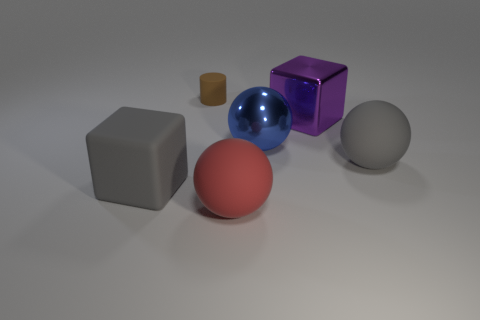What number of rubber cubes are there?
Your answer should be compact. 1. How many cubes are either large green rubber things or large blue metal objects?
Offer a very short reply. 0. There is another shiny sphere that is the same size as the red sphere; what color is it?
Keep it short and to the point. Blue. How many things are both in front of the purple cube and on the right side of the large blue object?
Offer a terse response. 1. What is the big red thing made of?
Give a very brief answer. Rubber. How many objects are red rubber balls or rubber things?
Ensure brevity in your answer.  4. There is a cube in front of the gray matte ball; is it the same size as the brown matte thing that is on the left side of the large red rubber object?
Your response must be concise. No. What number of other objects are there of the same size as the red matte sphere?
Ensure brevity in your answer.  4. How many things are either rubber things behind the large blue sphere or blue objects behind the red matte sphere?
Provide a succinct answer. 2. Is the material of the big blue thing the same as the block in front of the large gray matte sphere?
Ensure brevity in your answer.  No. 